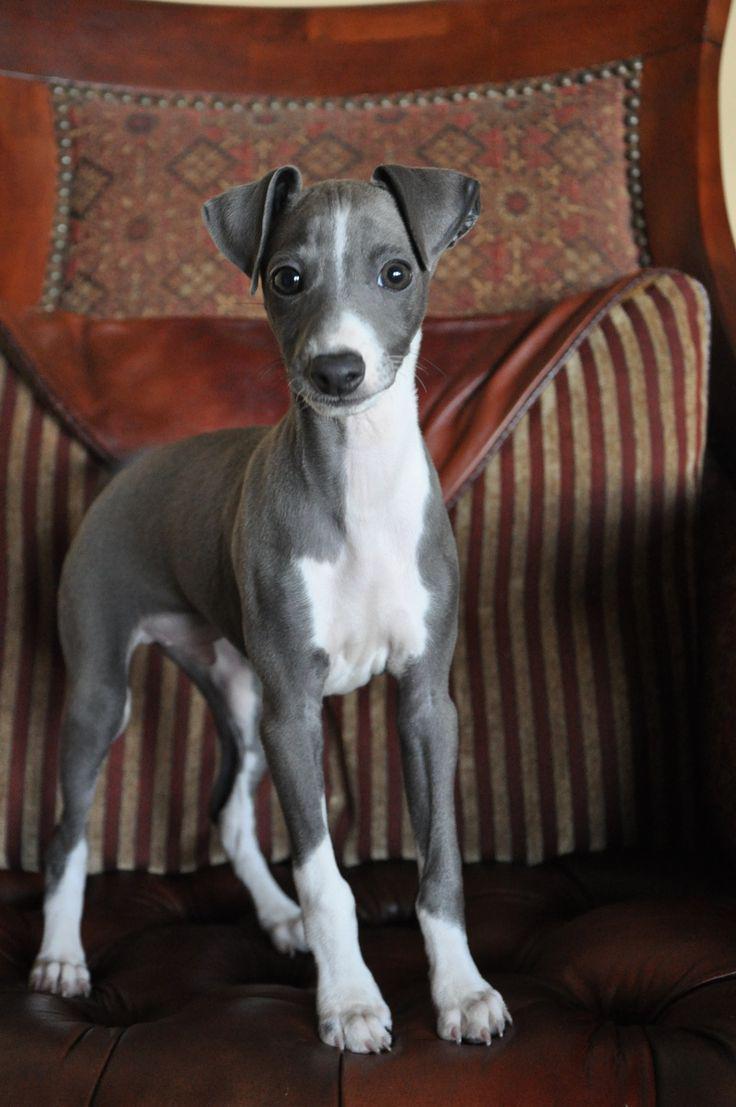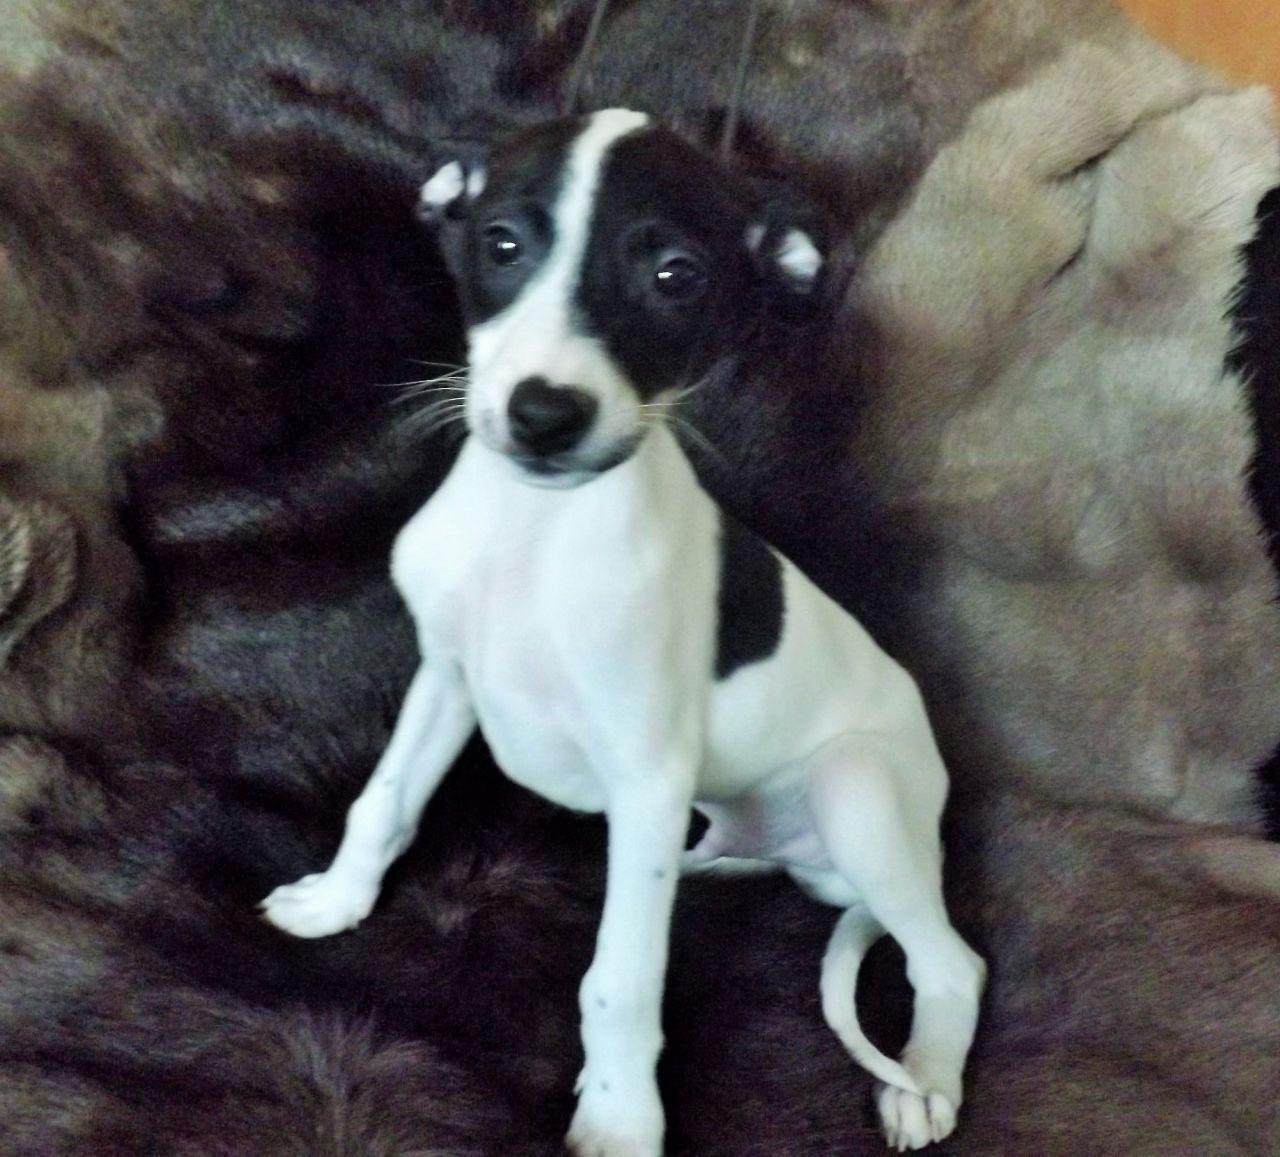The first image is the image on the left, the second image is the image on the right. Analyze the images presented: Is the assertion "At least one of the dogs is outside on the grass." valid? Answer yes or no. No. The first image is the image on the left, the second image is the image on the right. Examine the images to the left and right. Is the description "An image shows a standing dog with its white tail tip curled under and between its legs." accurate? Answer yes or no. No. 